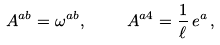<formula> <loc_0><loc_0><loc_500><loc_500>\ A ^ { a b } = \omega ^ { a b } , \quad \ A ^ { a 4 } = \frac { 1 } { \ell } \, e ^ { a } \, ,</formula> 